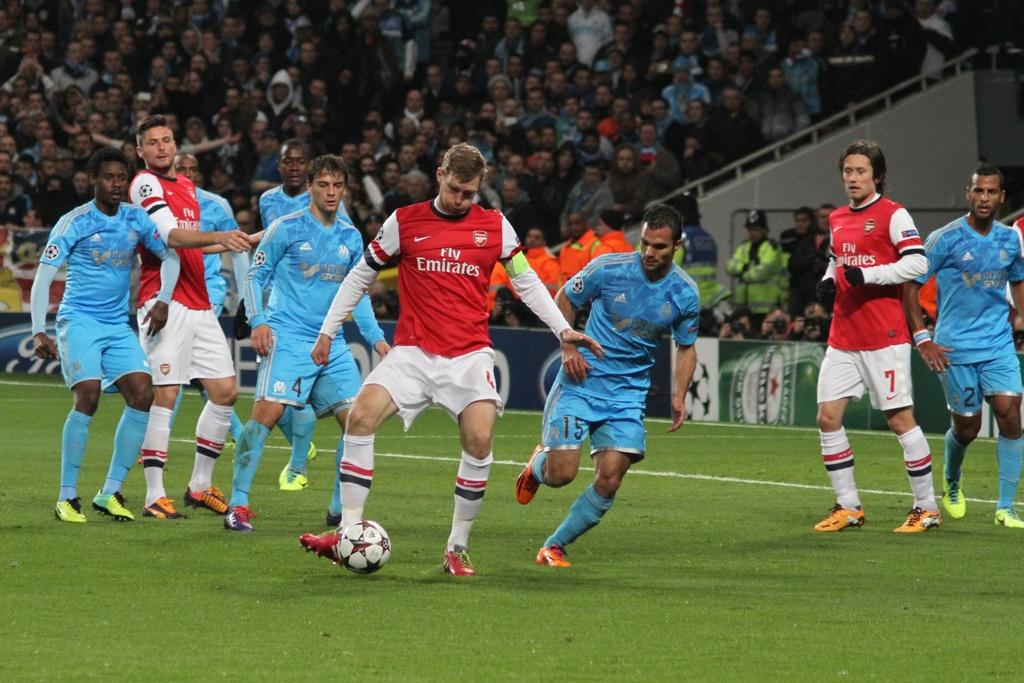<image>
Share a concise interpretation of the image provided. The Arsenal player wearing the Fly Emirates sponsored top controls the ball as his opponents look on. 